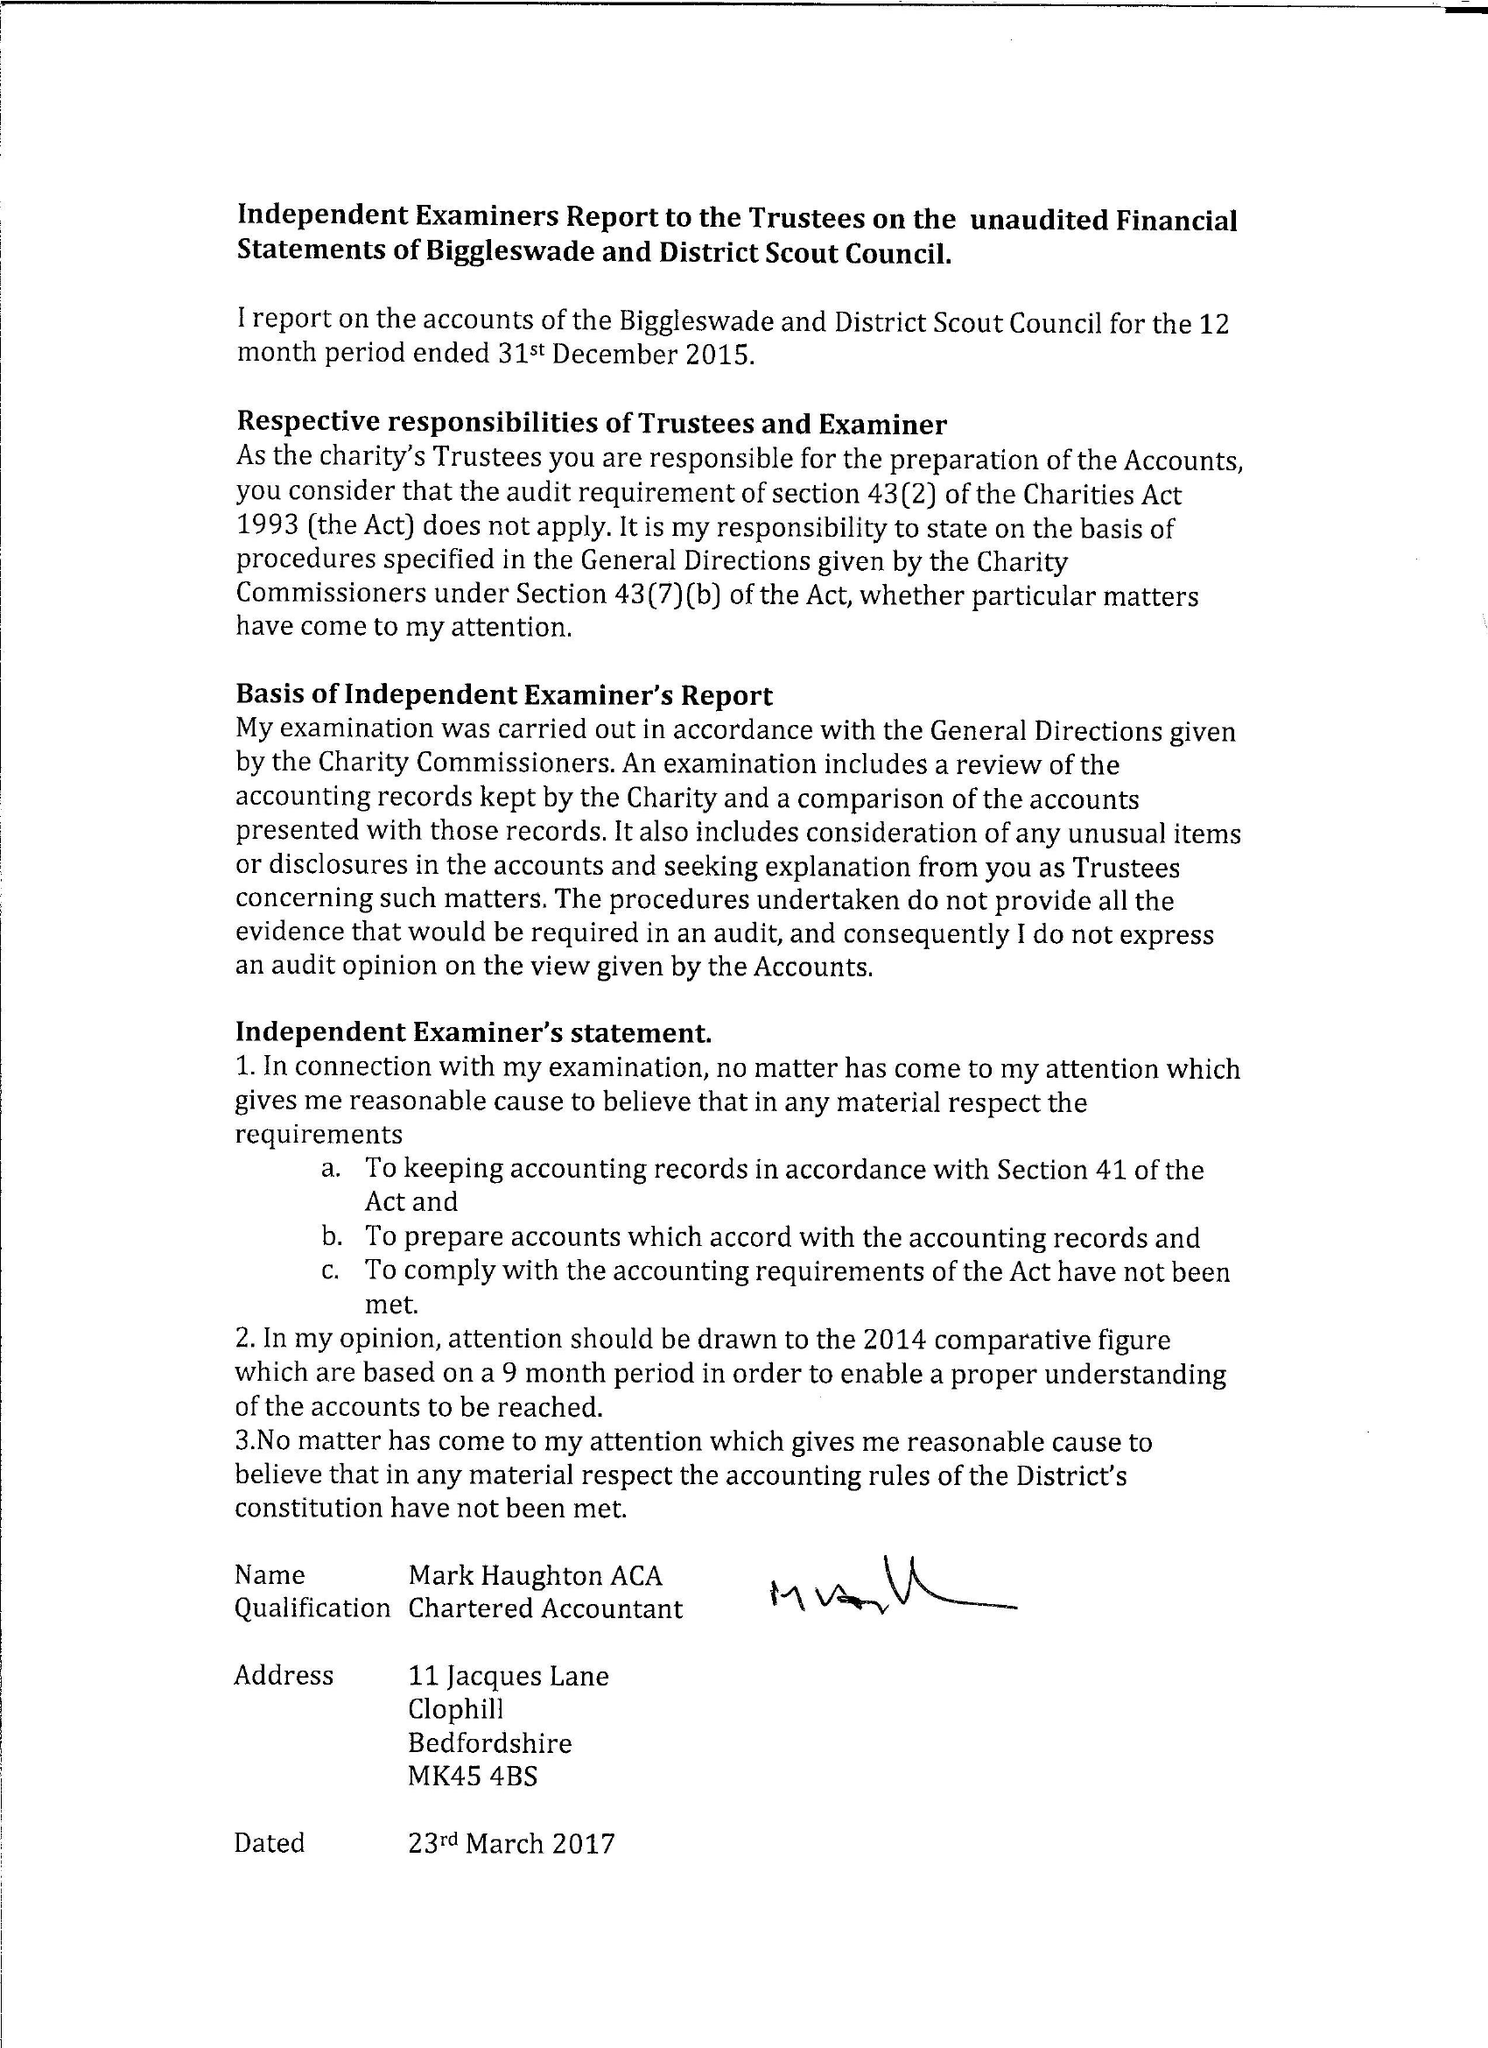What is the value for the address__street_line?
Answer the question using a single word or phrase. 20 SOUNDY PADDOCK 